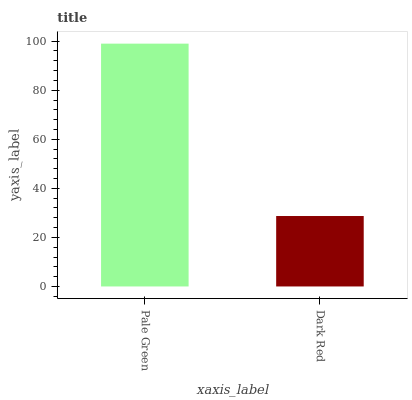Is Dark Red the minimum?
Answer yes or no. Yes. Is Pale Green the maximum?
Answer yes or no. Yes. Is Dark Red the maximum?
Answer yes or no. No. Is Pale Green greater than Dark Red?
Answer yes or no. Yes. Is Dark Red less than Pale Green?
Answer yes or no. Yes. Is Dark Red greater than Pale Green?
Answer yes or no. No. Is Pale Green less than Dark Red?
Answer yes or no. No. Is Pale Green the high median?
Answer yes or no. Yes. Is Dark Red the low median?
Answer yes or no. Yes. Is Dark Red the high median?
Answer yes or no. No. Is Pale Green the low median?
Answer yes or no. No. 